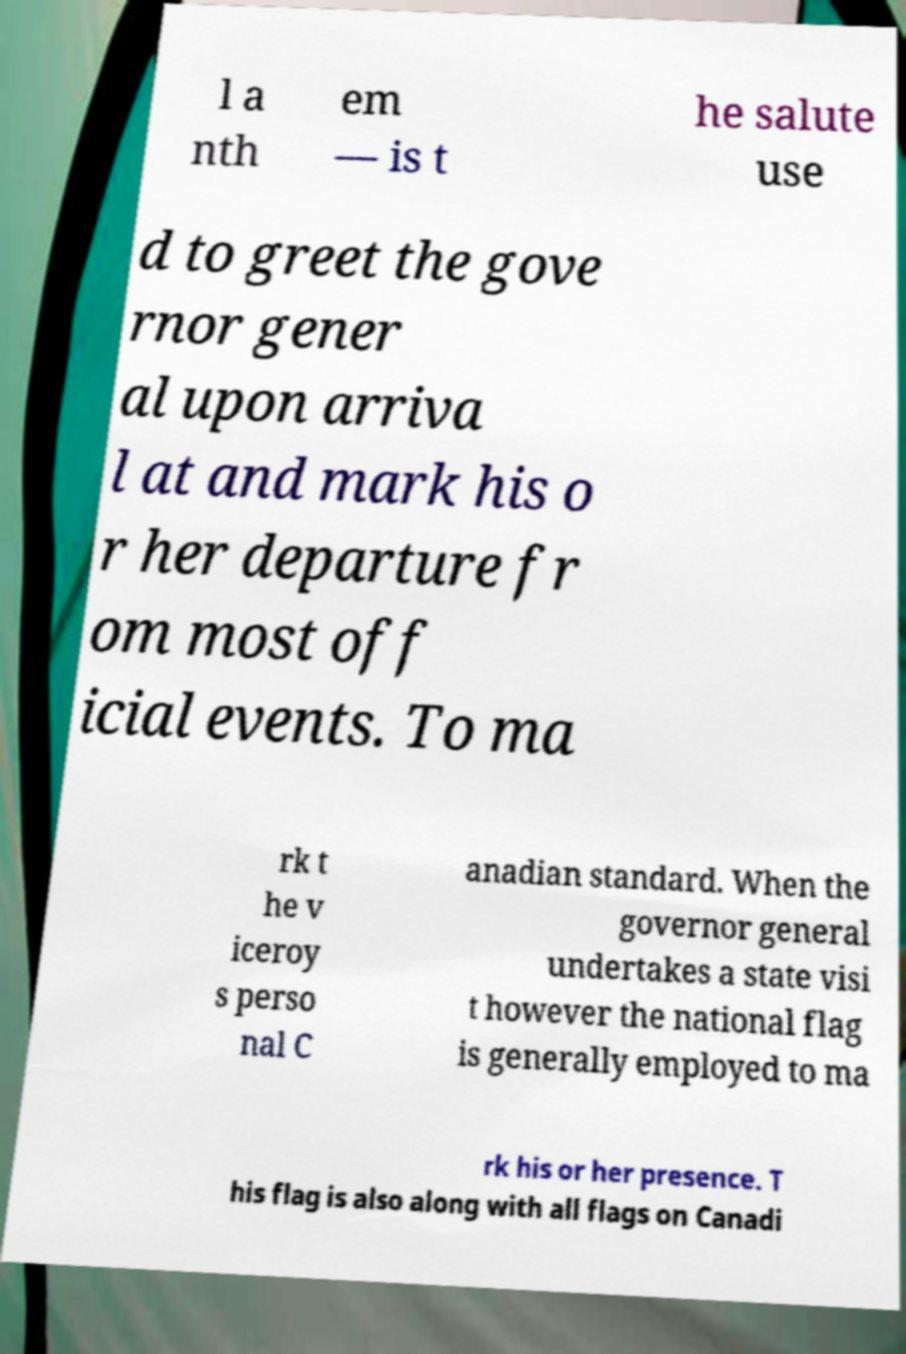Could you assist in decoding the text presented in this image and type it out clearly? l a nth em — is t he salute use d to greet the gove rnor gener al upon arriva l at and mark his o r her departure fr om most off icial events. To ma rk t he v iceroy s perso nal C anadian standard. When the governor general undertakes a state visi t however the national flag is generally employed to ma rk his or her presence. T his flag is also along with all flags on Canadi 